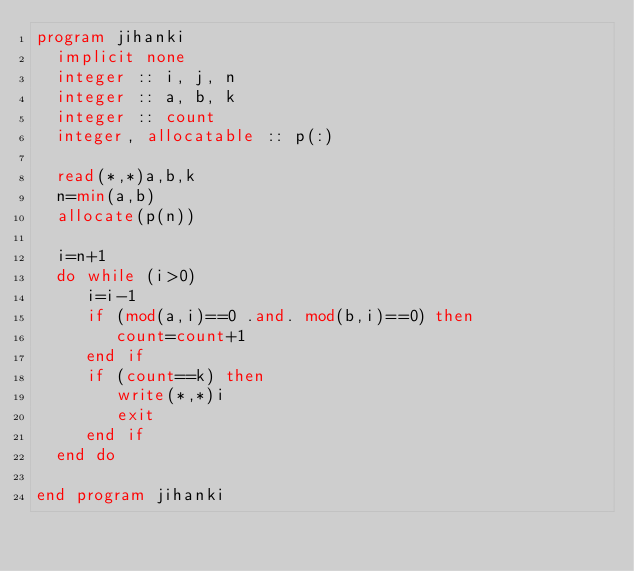Convert code to text. <code><loc_0><loc_0><loc_500><loc_500><_FORTRAN_>program jihanki
  implicit none
  integer :: i, j, n
  integer :: a, b, k
  integer :: count
  integer, allocatable :: p(:)

  read(*,*)a,b,k
  n=min(a,b)
  allocate(p(n))

  i=n+1
  do while (i>0)
     i=i-1
     if (mod(a,i)==0 .and. mod(b,i)==0) then
        count=count+1
     end if
     if (count==k) then
        write(*,*)i
        exit
     end if
  end do
  
end program jihanki</code> 